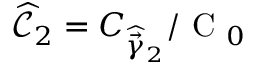Convert formula to latex. <formula><loc_0><loc_0><loc_500><loc_500>\widehat { \mathcal { C } } _ { 2 } = C _ { \widehat { \vec { \gamma } } _ { 2 } } / C _ { 0 }</formula> 